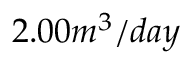Convert formula to latex. <formula><loc_0><loc_0><loc_500><loc_500>2 . 0 0 m ^ { 3 } / d a y</formula> 